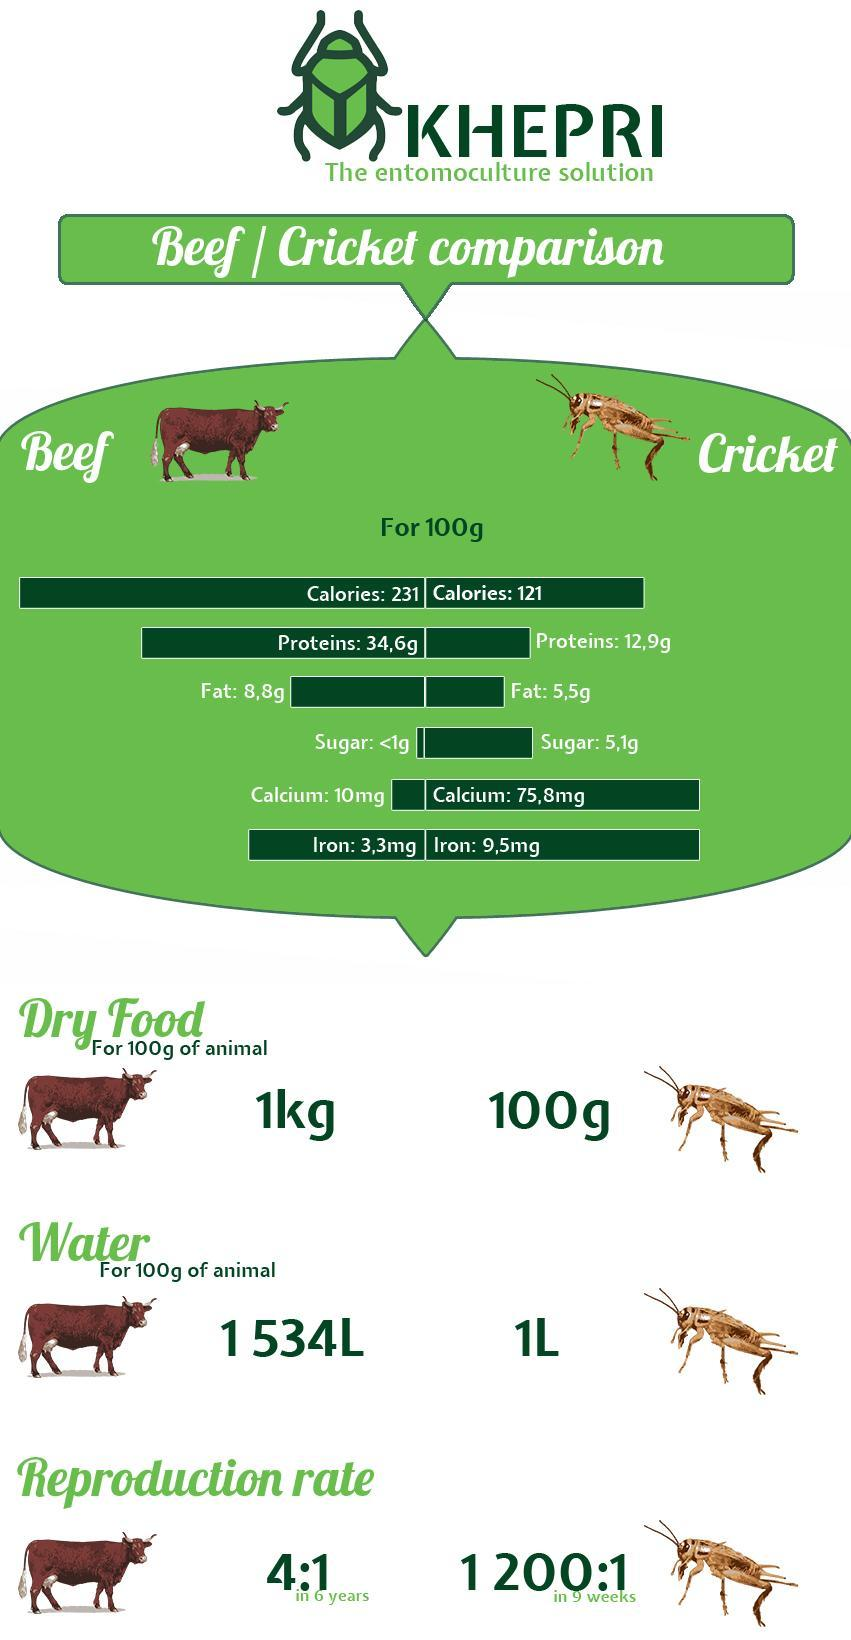How much calories does beef have for 100g
Answer the question with a short phrase. 231 what is the reproduction period of cow 6 years How much higher in grams is the fat in 100g of beef than 100g of cricket 3.3 what is the reproduction period of cricket 9 weeks Which has higher sugar, beef or cricket cricket How much calories does cricket have for 100g 121 